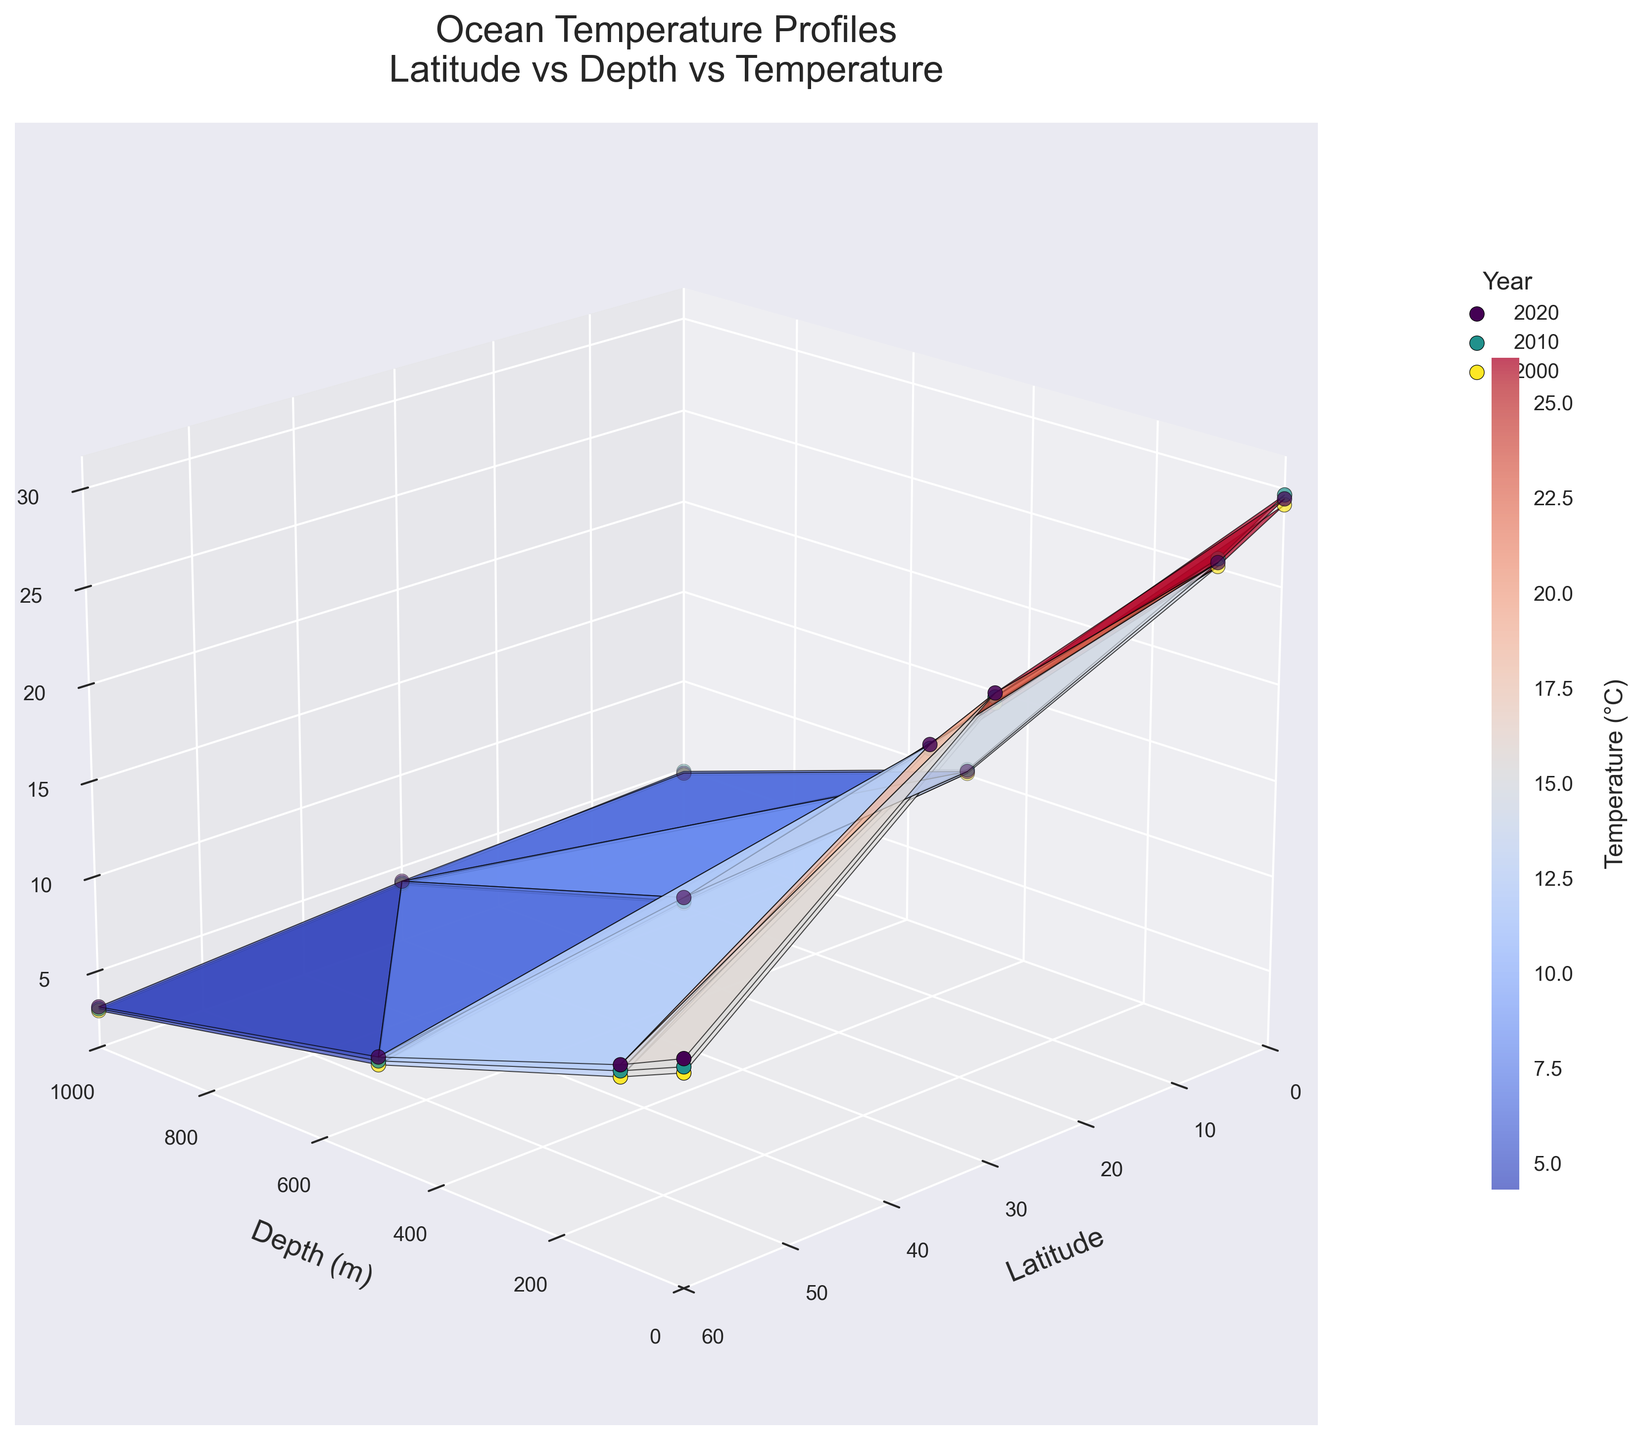What is the title of the figure? The title of the figure is displayed at the top, which describes what the plot is about.
Answer: Ocean Temperature Profiles What do the x-axis, y-axis, and z-axis represent in the plot? The plot's axes have labels that specify what each axis represents: the x-axis represents Latitude, the y-axis represents Depth in meters, and the z-axis represents Temperature in degrees Celsius.
Answer: Latitude, Depth (m), Temperature (°C) Which year's data is represented by the deeper blue color of the scatter points in the plot? The color gradient and the legend show that the deeper blue color corresponds to the year 2000.
Answer: 2000 What is the range of latitudes shown in the plot? The plot shows latitudes ranging from 0 to 60 degrees, as observed on the x-axis.
Answer: 0 to 60 degrees How does the ocean temperature change with depth at latitude 0 for the year 2020? By looking at the plot at latitude 0 and observing the temperature at different depths (0m, 100m, 500m, 1000m): the temperature decreases from 29.5°C at 0m to 4.8°C at 1000m.
Answer: It decreases Comparing the surface temperature (at 0m depth) at latitude 30 across the years shown, which year recorded the highest temperature? By comparing the surface temperatures at latitude 30 for all the years, the year 2020 recorded the highest temperature with 24.7°C.
Answer: 2020 What is the general trend in temperature change with depth for all latitudes and years shown? Observing the 3D plot, it is evident that the temperature generally decreases as depth increases, signifying cooler temperatures at greater depths across all latitudes and years.
Answer: Decreases At what depth and latitude would you find the lowest temperature in the year 2010? From the plot, the lowest temperature in 2010 (3.0°C) is found at a depth of 1000m and a latitude of 60 degrees.
Answer: 1000m, Latitude 60 What is the color range representing the temperature on the plot? The color bar indicates that the temperature is shown from cool colors (blue) representing lower temperatures to warm colors (red) representing higher temperatures.
Answer: Blue to Red How does the mean ocean temperature at 0m depth change from year 2000 to 2020 at latitude 0? Summing and averaging the surface temperatures at latitude 0 for 2000 (29.2°C), 2010 (29.7°C), and 2020 (29.5°C): (29.2 + 29.7 + 29.5) / 3 gives the mean temperature change over the years.
Answer: Increases from approx. 29.2°C to 29.7°C 